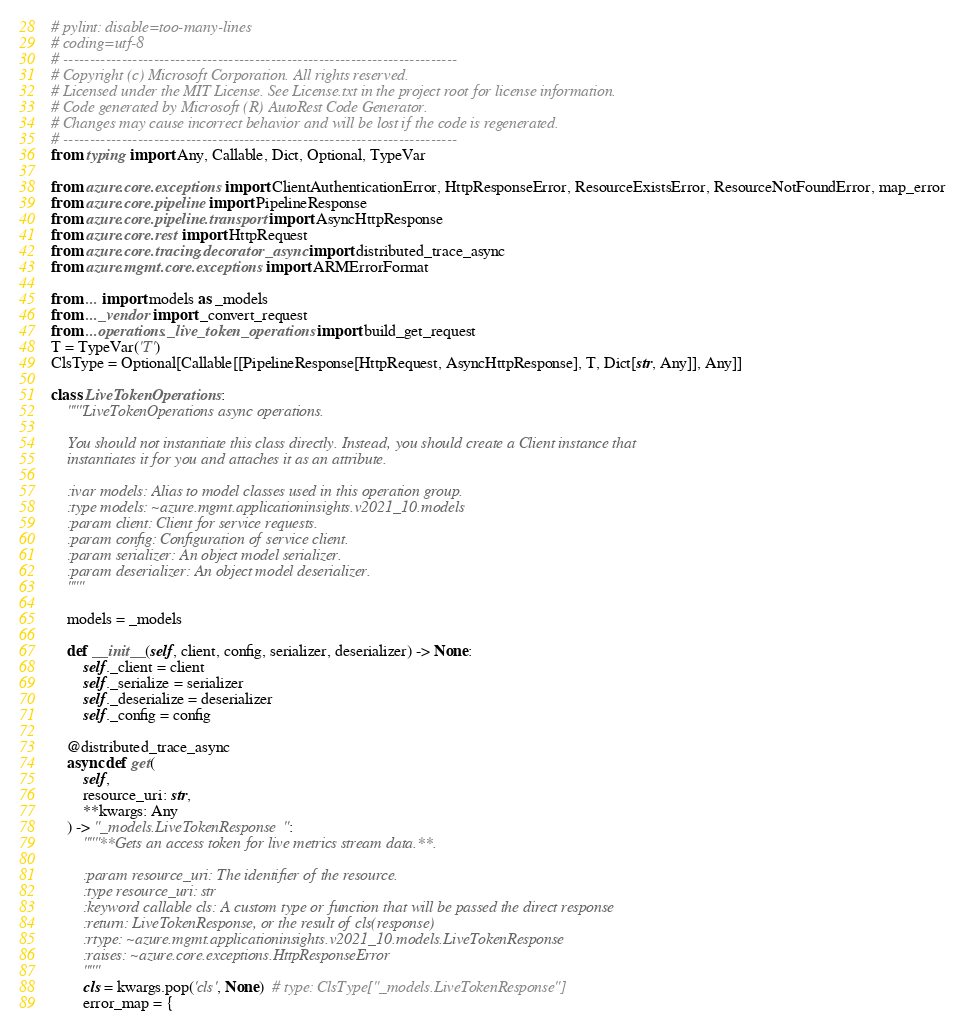Convert code to text. <code><loc_0><loc_0><loc_500><loc_500><_Python_># pylint: disable=too-many-lines
# coding=utf-8
# --------------------------------------------------------------------------
# Copyright (c) Microsoft Corporation. All rights reserved.
# Licensed under the MIT License. See License.txt in the project root for license information.
# Code generated by Microsoft (R) AutoRest Code Generator.
# Changes may cause incorrect behavior and will be lost if the code is regenerated.
# --------------------------------------------------------------------------
from typing import Any, Callable, Dict, Optional, TypeVar

from azure.core.exceptions import ClientAuthenticationError, HttpResponseError, ResourceExistsError, ResourceNotFoundError, map_error
from azure.core.pipeline import PipelineResponse
from azure.core.pipeline.transport import AsyncHttpResponse
from azure.core.rest import HttpRequest
from azure.core.tracing.decorator_async import distributed_trace_async
from azure.mgmt.core.exceptions import ARMErrorFormat

from ... import models as _models
from ..._vendor import _convert_request
from ...operations._live_token_operations import build_get_request
T = TypeVar('T')
ClsType = Optional[Callable[[PipelineResponse[HttpRequest, AsyncHttpResponse], T, Dict[str, Any]], Any]]

class LiveTokenOperations:
    """LiveTokenOperations async operations.

    You should not instantiate this class directly. Instead, you should create a Client instance that
    instantiates it for you and attaches it as an attribute.

    :ivar models: Alias to model classes used in this operation group.
    :type models: ~azure.mgmt.applicationinsights.v2021_10.models
    :param client: Client for service requests.
    :param config: Configuration of service client.
    :param serializer: An object model serializer.
    :param deserializer: An object model deserializer.
    """

    models = _models

    def __init__(self, client, config, serializer, deserializer) -> None:
        self._client = client
        self._serialize = serializer
        self._deserialize = deserializer
        self._config = config

    @distributed_trace_async
    async def get(
        self,
        resource_uri: str,
        **kwargs: Any
    ) -> "_models.LiveTokenResponse":
        """**Gets an access token for live metrics stream data.**.

        :param resource_uri: The identifier of the resource.
        :type resource_uri: str
        :keyword callable cls: A custom type or function that will be passed the direct response
        :return: LiveTokenResponse, or the result of cls(response)
        :rtype: ~azure.mgmt.applicationinsights.v2021_10.models.LiveTokenResponse
        :raises: ~azure.core.exceptions.HttpResponseError
        """
        cls = kwargs.pop('cls', None)  # type: ClsType["_models.LiveTokenResponse"]
        error_map = {</code> 